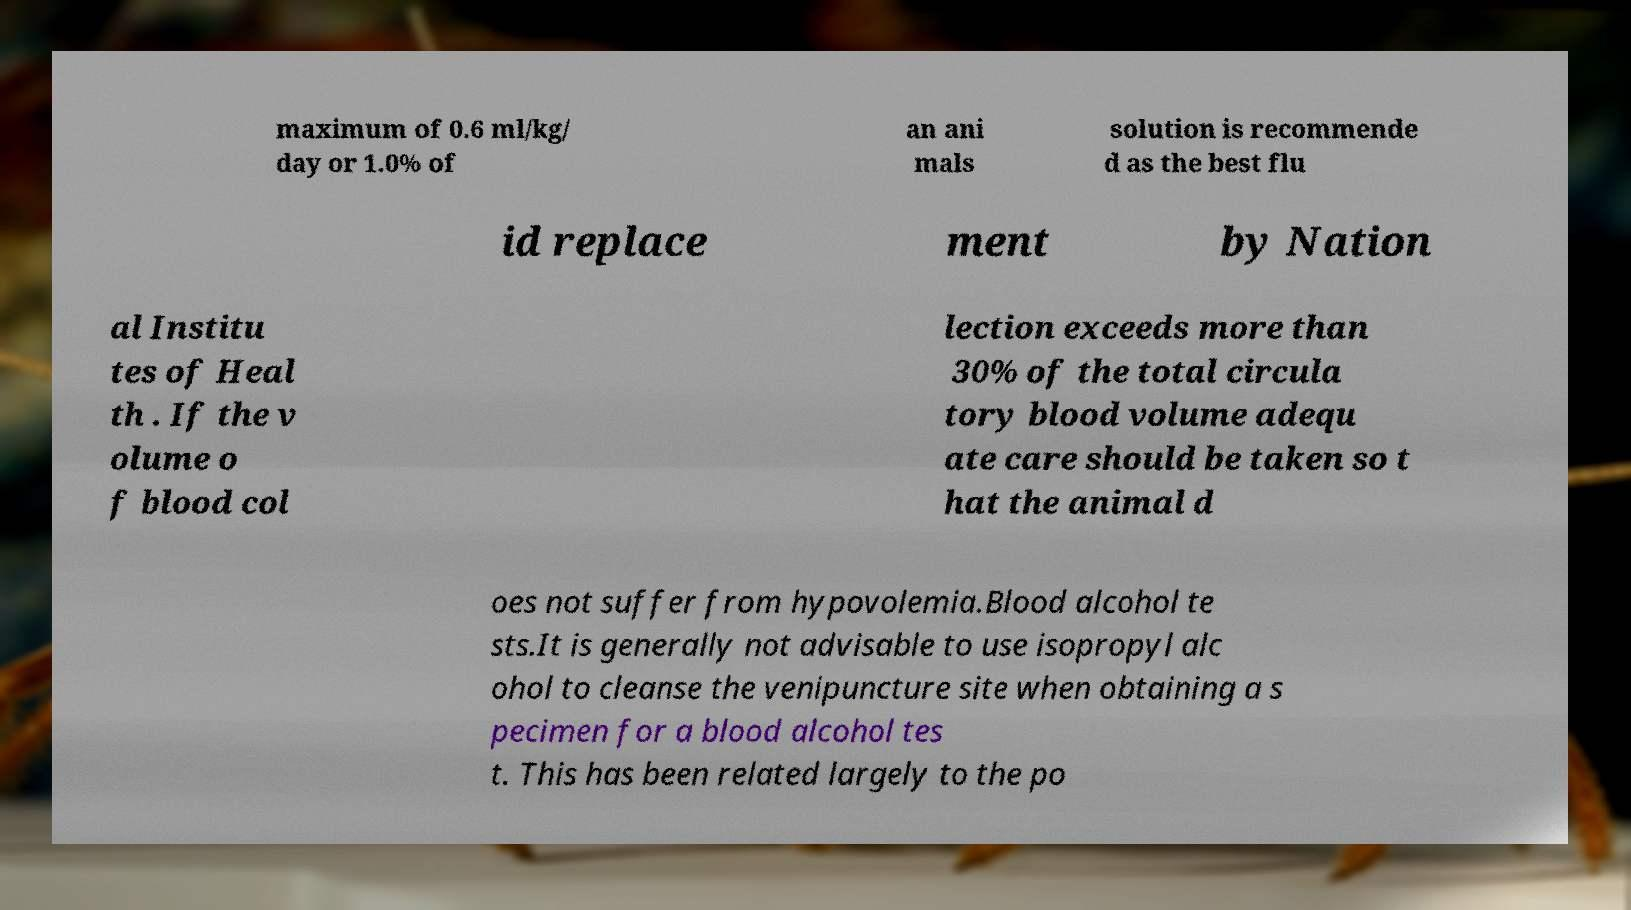Please read and relay the text visible in this image. What does it say? maximum of 0.6 ml/kg/ day or 1.0% of an ani mals solution is recommende d as the best flu id replace ment by Nation al Institu tes of Heal th . If the v olume o f blood col lection exceeds more than 30% of the total circula tory blood volume adequ ate care should be taken so t hat the animal d oes not suffer from hypovolemia.Blood alcohol te sts.It is generally not advisable to use isopropyl alc ohol to cleanse the venipuncture site when obtaining a s pecimen for a blood alcohol tes t. This has been related largely to the po 